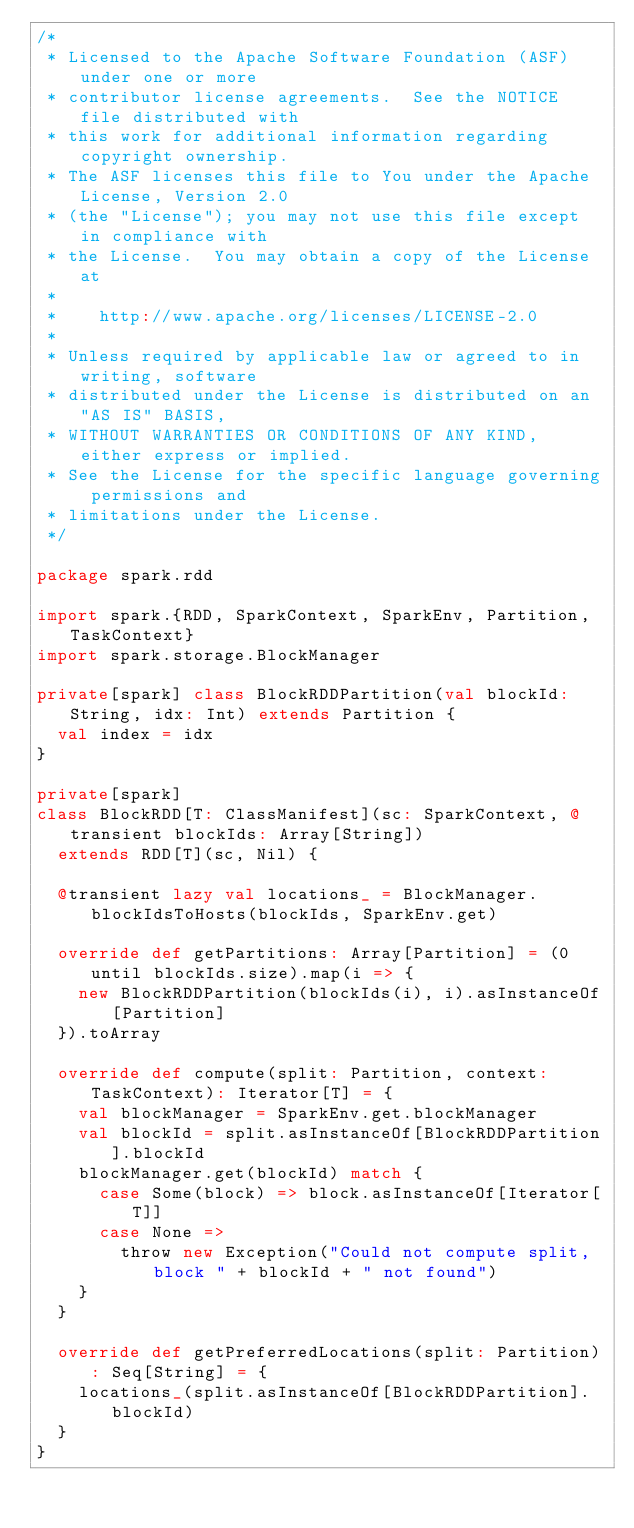Convert code to text. <code><loc_0><loc_0><loc_500><loc_500><_Scala_>/*
 * Licensed to the Apache Software Foundation (ASF) under one or more
 * contributor license agreements.  See the NOTICE file distributed with
 * this work for additional information regarding copyright ownership.
 * The ASF licenses this file to You under the Apache License, Version 2.0
 * (the "License"); you may not use this file except in compliance with
 * the License.  You may obtain a copy of the License at
 *
 *    http://www.apache.org/licenses/LICENSE-2.0
 *
 * Unless required by applicable law or agreed to in writing, software
 * distributed under the License is distributed on an "AS IS" BASIS,
 * WITHOUT WARRANTIES OR CONDITIONS OF ANY KIND, either express or implied.
 * See the License for the specific language governing permissions and
 * limitations under the License.
 */

package spark.rdd

import spark.{RDD, SparkContext, SparkEnv, Partition, TaskContext}
import spark.storage.BlockManager

private[spark] class BlockRDDPartition(val blockId: String, idx: Int) extends Partition {
  val index = idx
}

private[spark]
class BlockRDD[T: ClassManifest](sc: SparkContext, @transient blockIds: Array[String])
  extends RDD[T](sc, Nil) {

  @transient lazy val locations_ = BlockManager.blockIdsToHosts(blockIds, SparkEnv.get)

  override def getPartitions: Array[Partition] = (0 until blockIds.size).map(i => {
    new BlockRDDPartition(blockIds(i), i).asInstanceOf[Partition]
  }).toArray

  override def compute(split: Partition, context: TaskContext): Iterator[T] = {
    val blockManager = SparkEnv.get.blockManager
    val blockId = split.asInstanceOf[BlockRDDPartition].blockId
    blockManager.get(blockId) match {
      case Some(block) => block.asInstanceOf[Iterator[T]]
      case None =>
        throw new Exception("Could not compute split, block " + blockId + " not found")
    }
  }

  override def getPreferredLocations(split: Partition): Seq[String] = {
    locations_(split.asInstanceOf[BlockRDDPartition].blockId)
  }
}

</code> 